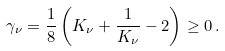Convert formula to latex. <formula><loc_0><loc_0><loc_500><loc_500>\gamma _ { \nu } = \frac { 1 } { 8 } \left ( K _ { \nu } + \frac { 1 } { K _ { \nu } } - 2 \right ) \geq 0 \, .</formula> 